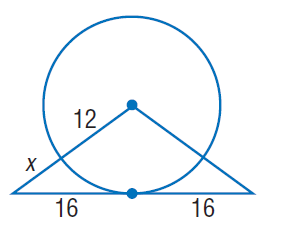Answer the mathemtical geometry problem and directly provide the correct option letter.
Question: Find x. Assume that segments that appear to be tangent are tangent.
Choices: A: 8 B: 12 C: 16 D: 32 A 